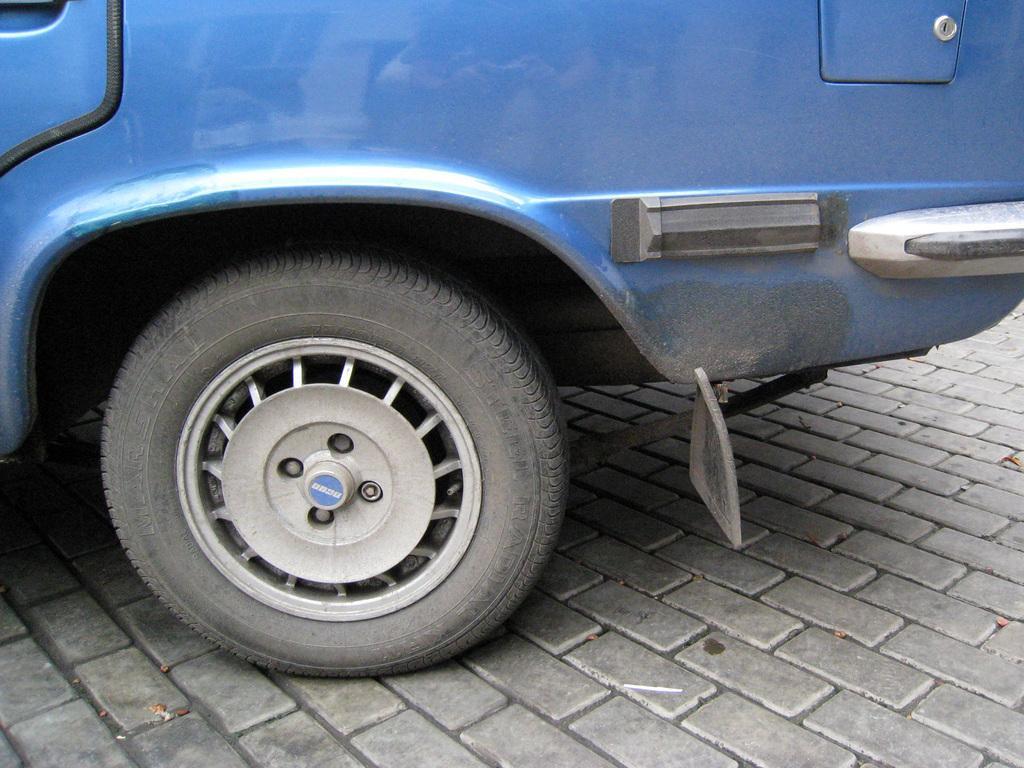Describe this image in one or two sentences. In this image I can see a vehicle on the ground and a tier. 